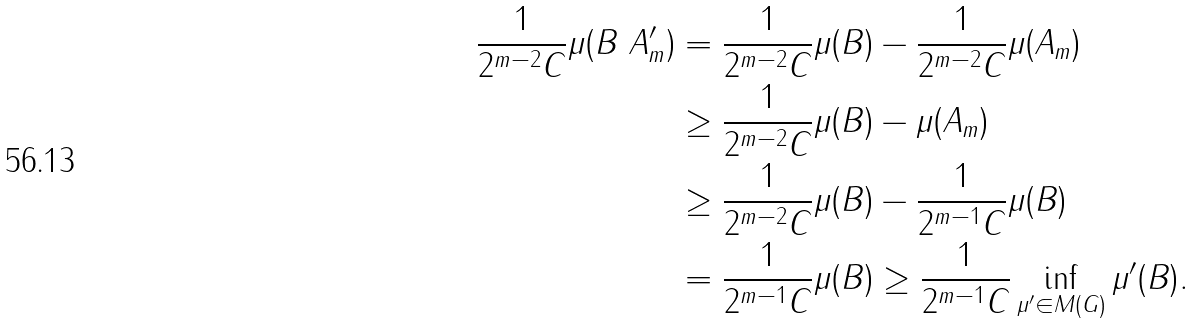Convert formula to latex. <formula><loc_0><loc_0><loc_500><loc_500>\frac { 1 } { 2 ^ { m - 2 } C } \mu ( B \ A _ { m } ^ { \prime } ) & = \frac { 1 } { 2 ^ { m - 2 } C } \mu ( B ) - \frac { 1 } { 2 ^ { m - 2 } C } \mu ( A _ { m } ) \\ & \geq \frac { 1 } { 2 ^ { m - 2 } C } \mu ( B ) - \mu ( A _ { m } ) \\ & \geq \frac { 1 } { 2 ^ { m - 2 } C } \mu ( B ) - \frac { 1 } { 2 ^ { m - 1 } C } \mu ( B ) \\ & = \frac { 1 } { 2 ^ { m - 1 } C } \mu ( B ) \geq \frac { 1 } { 2 ^ { m - 1 } C } \inf _ { \mu ^ { \prime } \in M ( G ) } \mu ^ { \prime } ( B ) .</formula> 